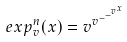Convert formula to latex. <formula><loc_0><loc_0><loc_500><loc_500>e x p _ { v } ^ { n } ( x ) = v ^ { v ^ { - ^ { - ^ { v ^ { x } } } } }</formula> 